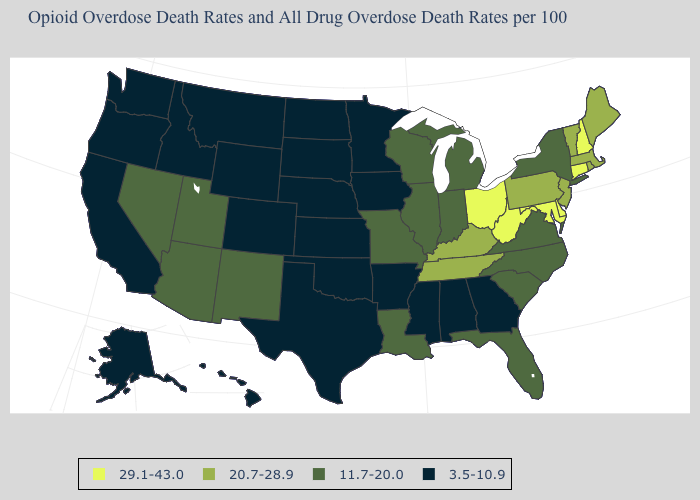What is the highest value in the USA?
Concise answer only. 29.1-43.0. How many symbols are there in the legend?
Give a very brief answer. 4. What is the value of Connecticut?
Keep it brief. 29.1-43.0. Is the legend a continuous bar?
Keep it brief. No. Which states have the highest value in the USA?
Answer briefly. Connecticut, Delaware, Maryland, New Hampshire, Ohio, West Virginia. Does Nevada have the highest value in the USA?
Short answer required. No. Is the legend a continuous bar?
Short answer required. No. Does Rhode Island have the lowest value in the Northeast?
Concise answer only. No. Among the states that border Arkansas , does Tennessee have the highest value?
Answer briefly. Yes. What is the value of Idaho?
Write a very short answer. 3.5-10.9. What is the lowest value in states that border Maryland?
Concise answer only. 11.7-20.0. Does Missouri have the same value as New York?
Short answer required. Yes. Among the states that border Illinois , which have the lowest value?
Short answer required. Iowa. What is the highest value in states that border Connecticut?
Concise answer only. 20.7-28.9. Which states have the highest value in the USA?
Quick response, please. Connecticut, Delaware, Maryland, New Hampshire, Ohio, West Virginia. 